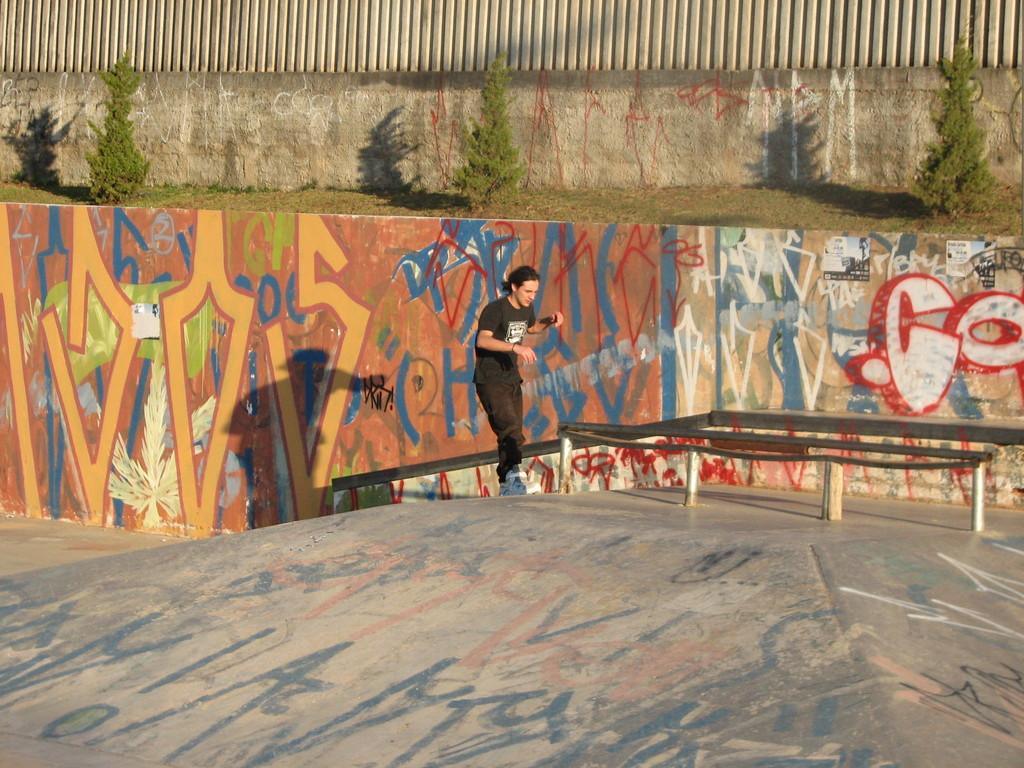What is the man in the image doing? The man is standing on a platform in the image. What can be seen on the walls in the image? The walls have paintings on them. What type of natural scenery is visible in the background of the image? There are trees visible in the background of the image. What type of space vehicle can be seen in the image? There is no space vehicle present in the image. What is the man using to whip the trees in the background? The man is not whipping the trees in the background, and there is no whip present in the image. 